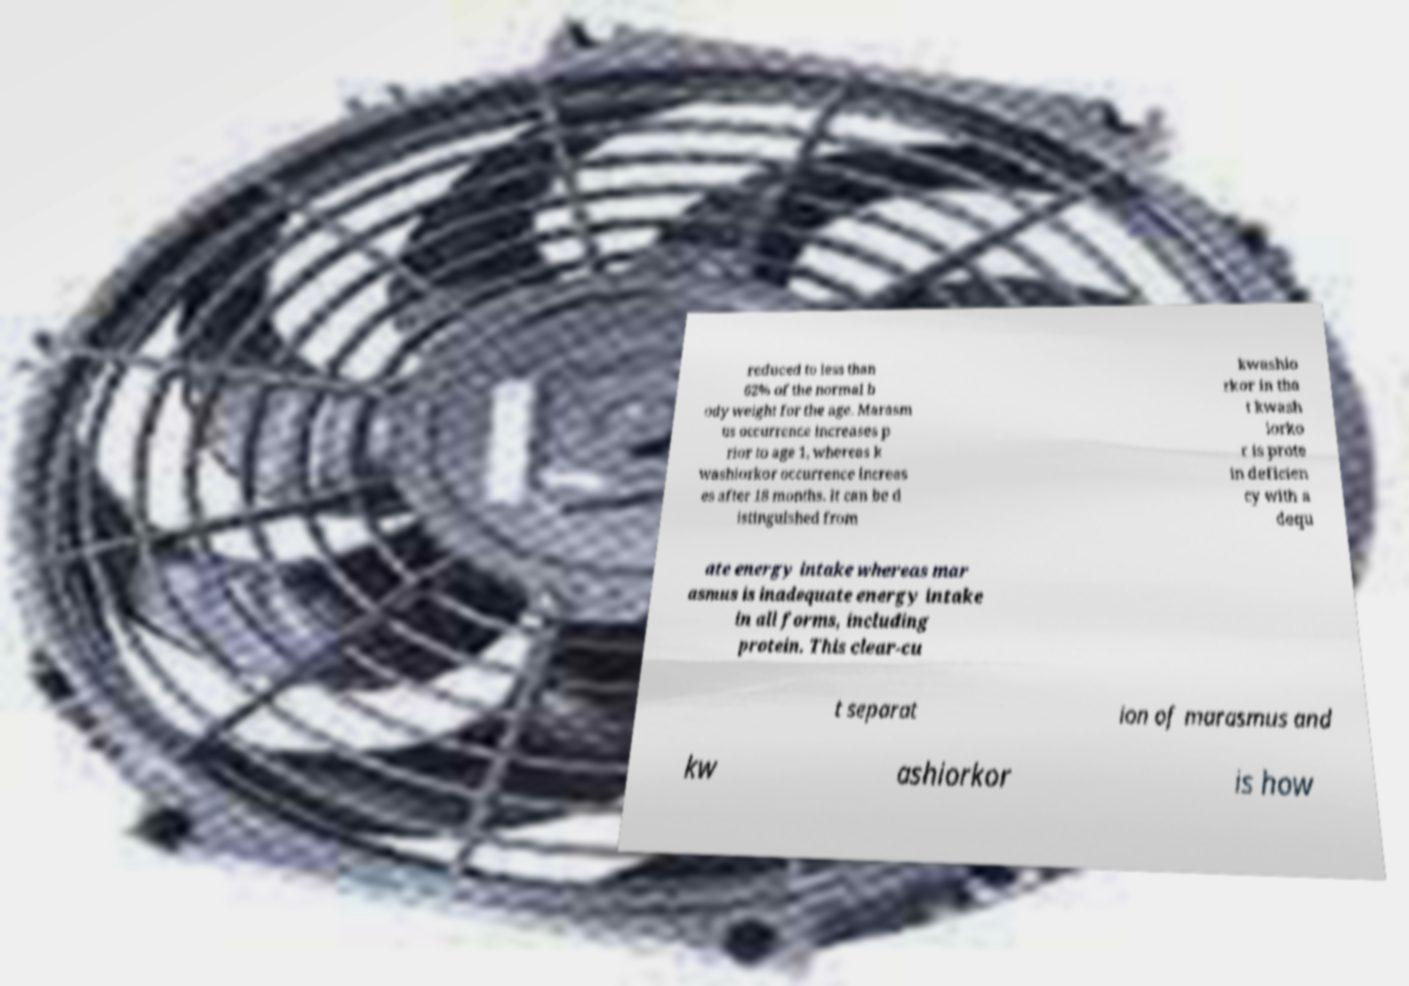What messages or text are displayed in this image? I need them in a readable, typed format. reduced to less than 62% of the normal b ody weight for the age. Marasm us occurrence increases p rior to age 1, whereas k washiorkor occurrence increas es after 18 months. It can be d istinguished from kwashio rkor in tha t kwash iorko r is prote in deficien cy with a dequ ate energy intake whereas mar asmus is inadequate energy intake in all forms, including protein. This clear-cu t separat ion of marasmus and kw ashiorkor is how 